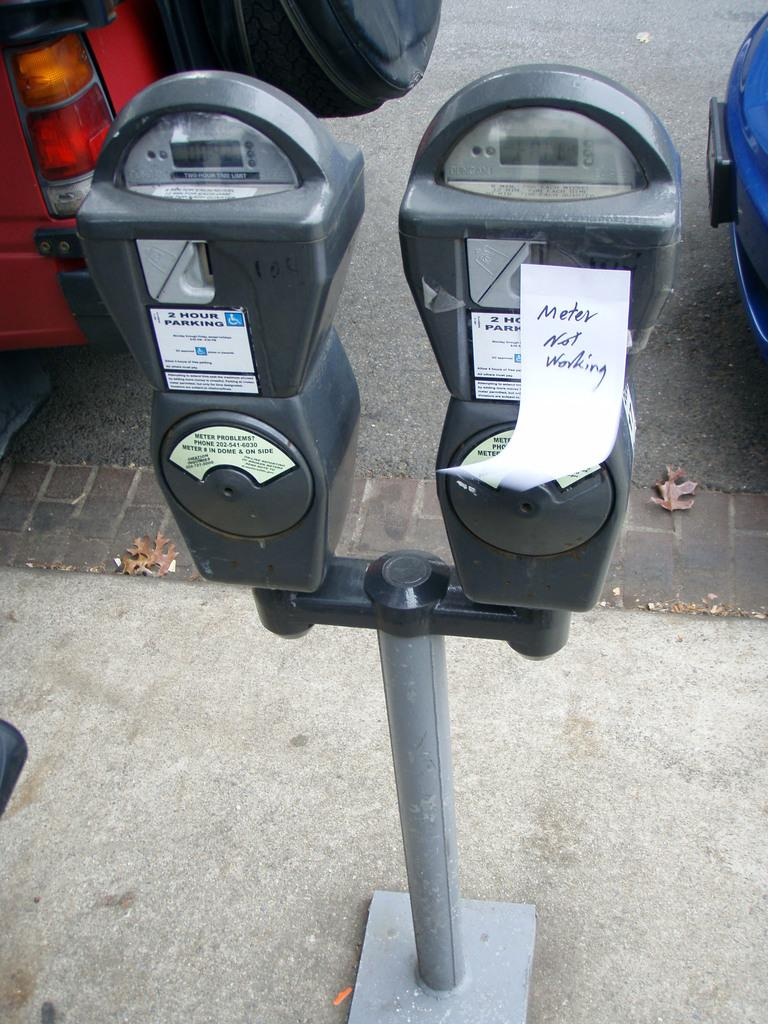Provide a one-sentence caption for the provided image. Two parking meters next to one another and one has a note that says Meter Not Working on it. 